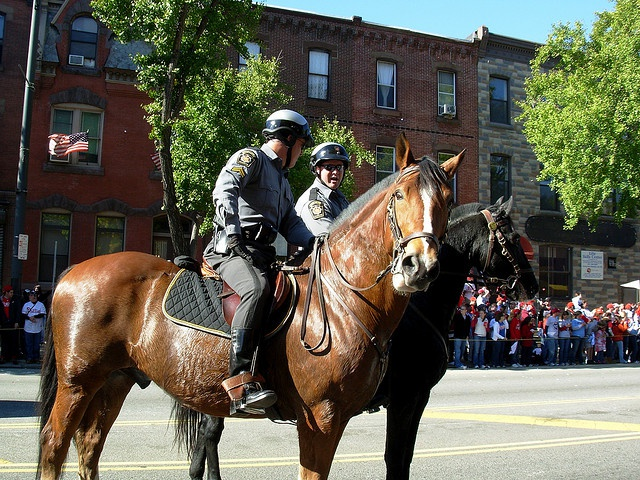Describe the objects in this image and their specific colors. I can see horse in black, brown, gray, and maroon tones, horse in black, gray, ivory, and darkgray tones, people in black, white, darkgray, and gray tones, people in black, gray, maroon, and white tones, and people in black, white, gray, and darkgray tones in this image. 